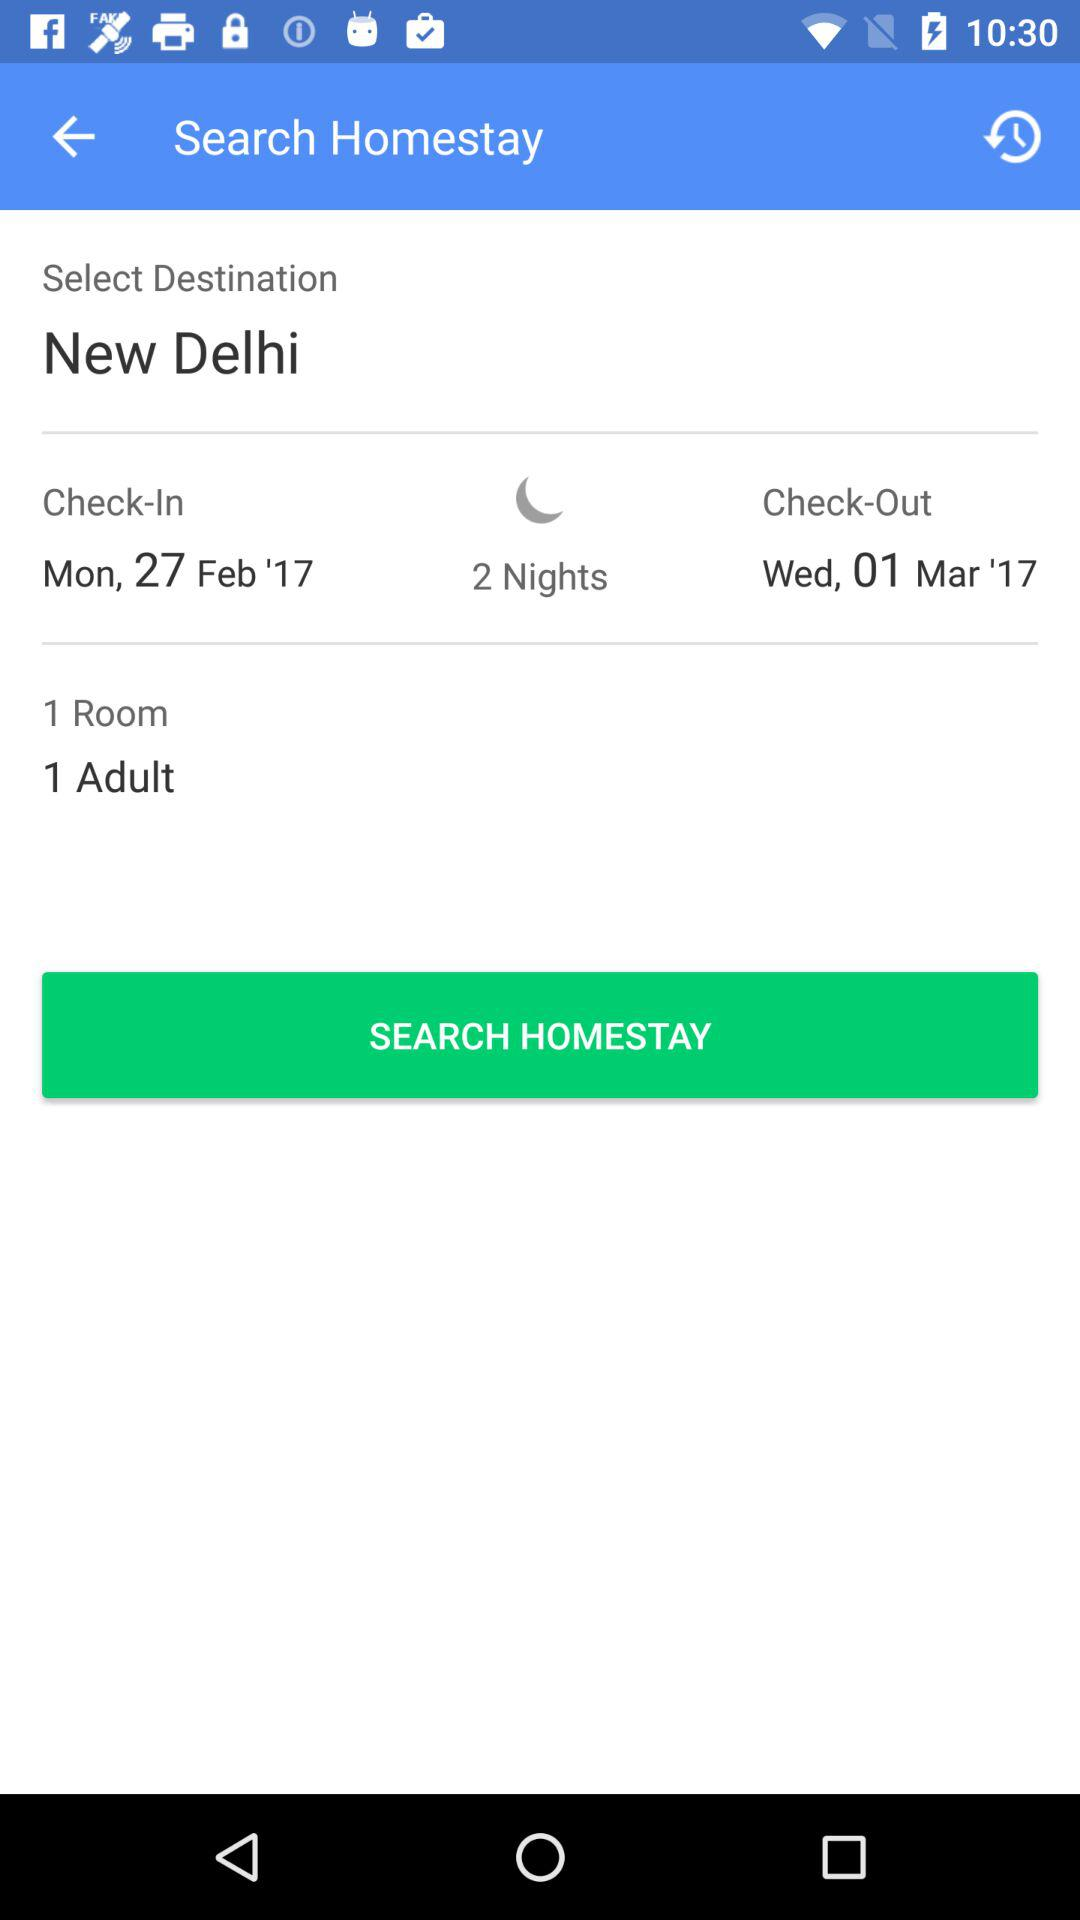When will the check-in be done? The check-in will be done on Monday, February 27, 2017. 